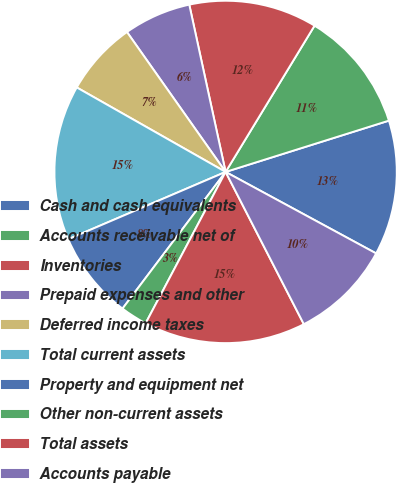Convert chart to OTSL. <chart><loc_0><loc_0><loc_500><loc_500><pie_chart><fcel>Cash and cash equivalents<fcel>Accounts receivable net of<fcel>Inventories<fcel>Prepaid expenses and other<fcel>Deferred income taxes<fcel>Total current assets<fcel>Property and equipment net<fcel>Other non-current assets<fcel>Total assets<fcel>Accounts payable<nl><fcel>12.74%<fcel>11.46%<fcel>12.1%<fcel>6.37%<fcel>7.01%<fcel>14.65%<fcel>8.28%<fcel>2.55%<fcel>15.29%<fcel>9.55%<nl></chart> 